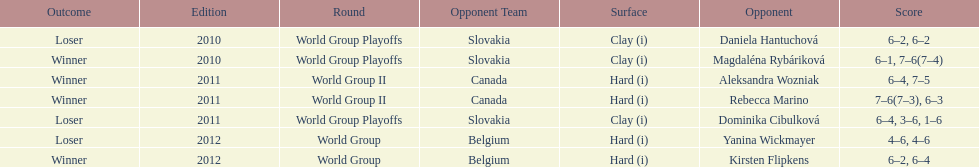Did they beat canada in more or less than 3 matches? Less. 